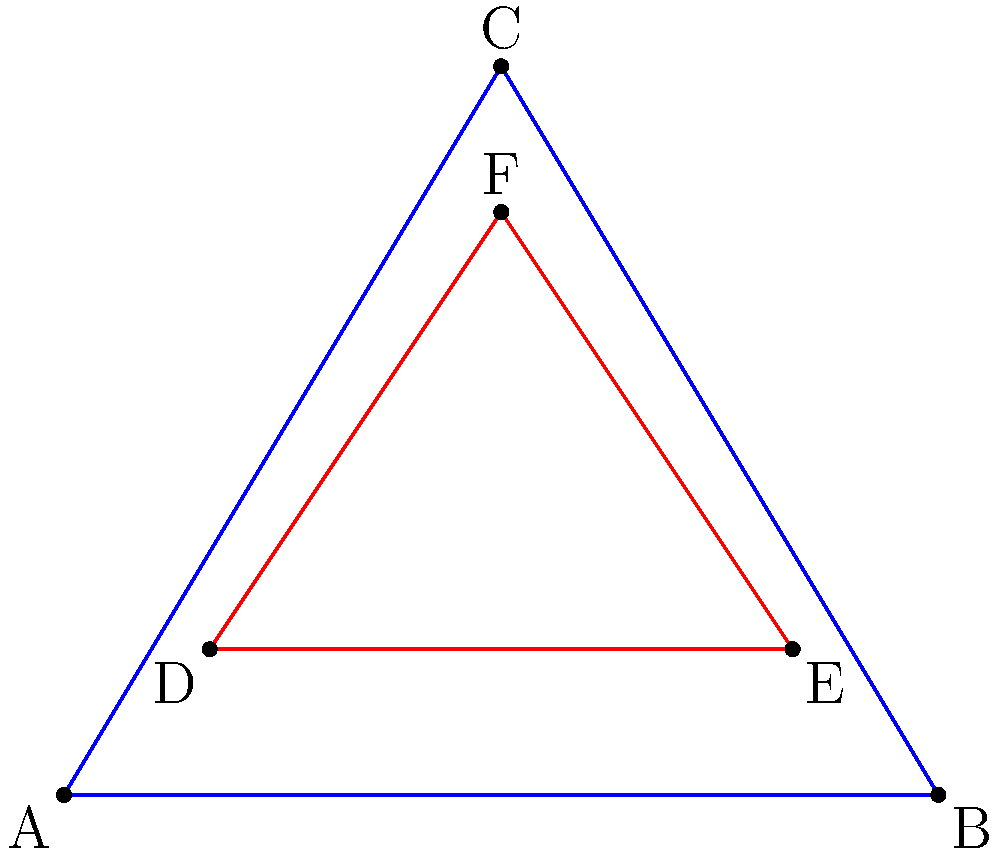In a multi-layered set design, two triangular platforms are overlapping. Triangle ABC represents the base layer, while triangle DEF represents the upper layer. Find the coordinates of the intersection points (I1, I2, I3, I4) between these two triangles to determine where supports should be placed to create a stable, interconnected structure.

Given:
- Triangle ABC: A(0,0), B(6,0), C(3,5)
- Triangle DEF: D(1,1), E(5,1), F(3,4) To find the intersection points, we need to determine where the sides of the triangles intersect:

1. Find intersections of AB with DE, DF, and EF:
   AB: y = 0
   DE: y = 1
   DF: y - 1 = (3/2)(x - 1)
   EF: y - 1 = (3/4)(x - 5)
   
   I1: AB ∩ DF at (1,0)
   I2: AB ∩ EF at (5,0)

2. Find intersections of BC with DE, DF, and EF:
   BC: y - 5 = (-5/3)(x - 3)
   
   I3: BC ∩ EF at (45/11, 40/11) ≈ (4.09, 3.64)

3. Find intersections of AC with DE, DF, and EF:
   AC: y = (5/3)x
   
   I4: AC ∩ DE at (3/5, 1) = (0.6, 1)

Therefore, the four intersection points are:
I1(1,0), I2(5,0), I3(45/11, 40/11), and I4(3/5, 1)
Answer: I1(1,0), I2(5,0), I3(45/11, 40/11), I4(3/5, 1) 